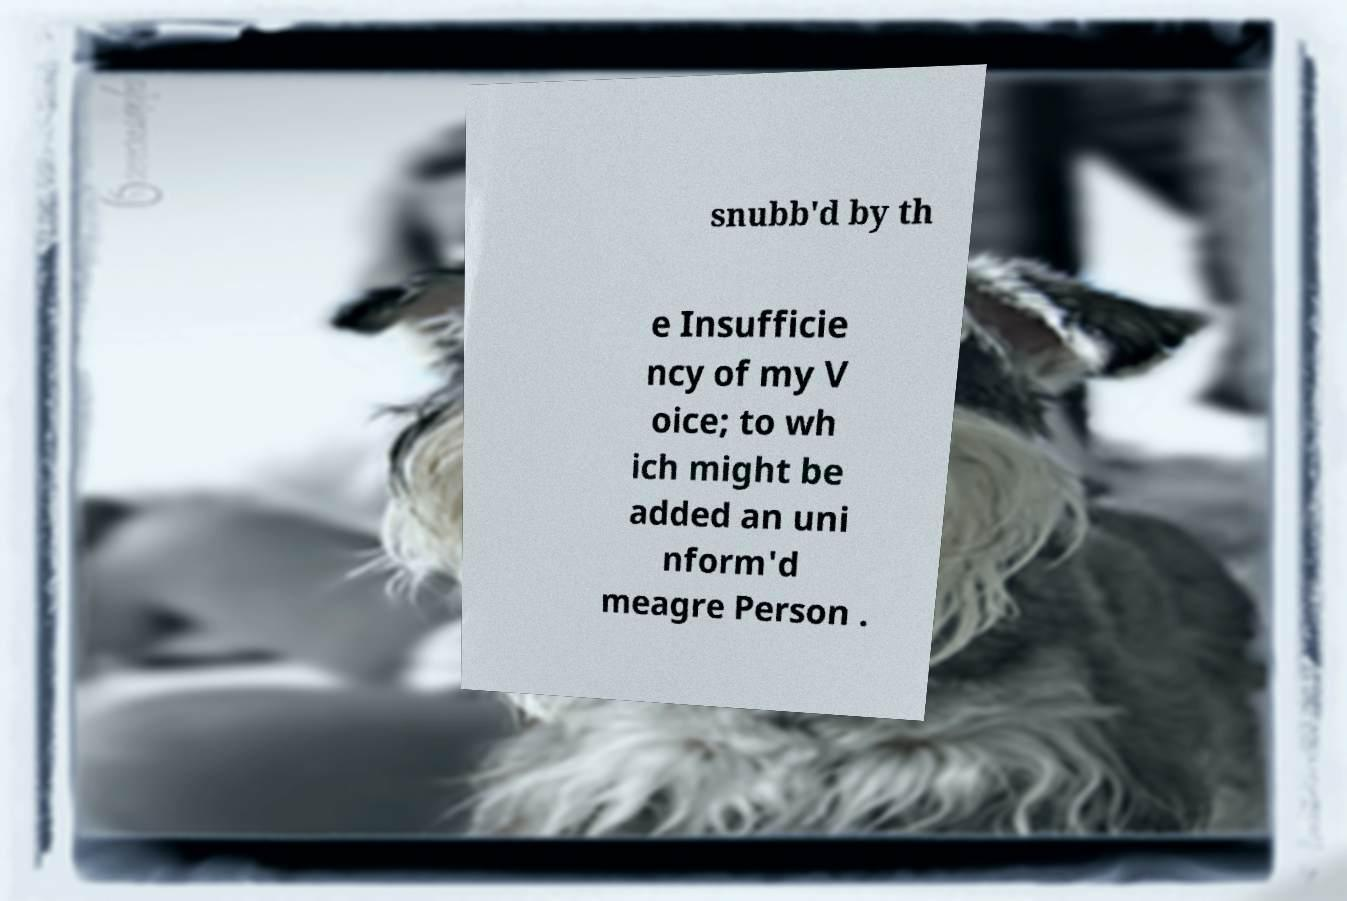There's text embedded in this image that I need extracted. Can you transcribe it verbatim? snubb'd by th e Insufficie ncy of my V oice; to wh ich might be added an uni nform'd meagre Person . 